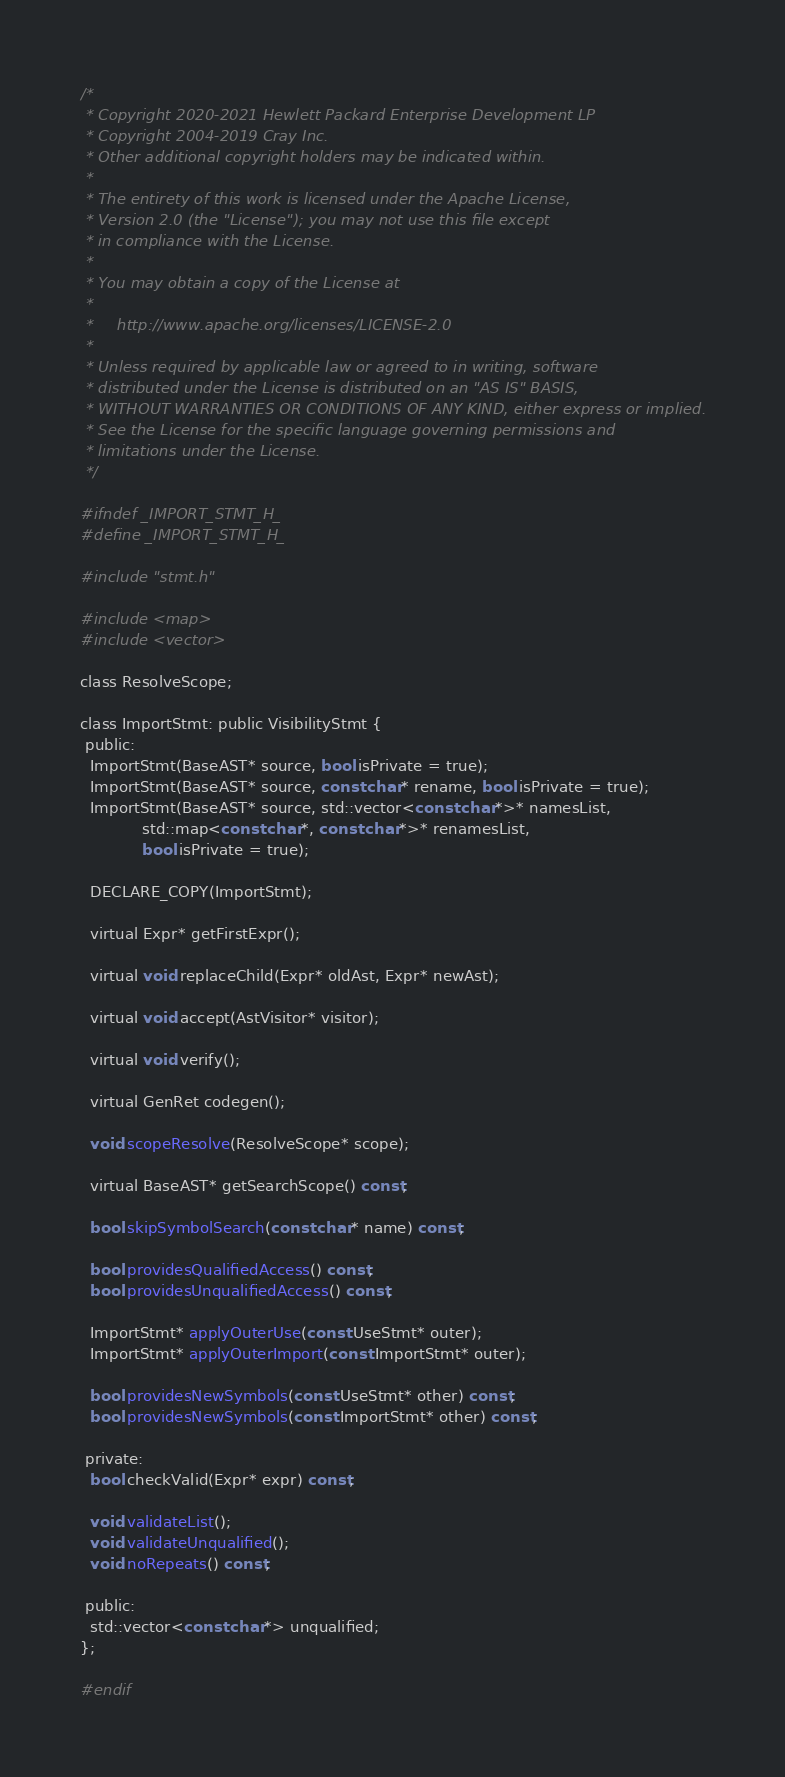Convert code to text. <code><loc_0><loc_0><loc_500><loc_500><_C_>/*
 * Copyright 2020-2021 Hewlett Packard Enterprise Development LP
 * Copyright 2004-2019 Cray Inc.
 * Other additional copyright holders may be indicated within.
 *
 * The entirety of this work is licensed under the Apache License,
 * Version 2.0 (the "License"); you may not use this file except
 * in compliance with the License.
 *
 * You may obtain a copy of the License at
 *
 *     http://www.apache.org/licenses/LICENSE-2.0
 *
 * Unless required by applicable law or agreed to in writing, software
 * distributed under the License is distributed on an "AS IS" BASIS,
 * WITHOUT WARRANTIES OR CONDITIONS OF ANY KIND, either express or implied.
 * See the License for the specific language governing permissions and
 * limitations under the License.
 */

#ifndef _IMPORT_STMT_H_
#define _IMPORT_STMT_H_

#include "stmt.h"

#include <map>
#include <vector>

class ResolveScope;

class ImportStmt: public VisibilityStmt {
 public:
  ImportStmt(BaseAST* source, bool isPrivate = true);
  ImportStmt(BaseAST* source, const char* rename, bool isPrivate = true);
  ImportStmt(BaseAST* source, std::vector<const char*>* namesList,
             std::map<const char*, const char*>* renamesList,
             bool isPrivate = true);

  DECLARE_COPY(ImportStmt);

  virtual Expr* getFirstExpr();

  virtual void replaceChild(Expr* oldAst, Expr* newAst);

  virtual void accept(AstVisitor* visitor);

  virtual void verify();

  virtual GenRet codegen();

  void scopeResolve(ResolveScope* scope);

  virtual BaseAST* getSearchScope() const;

  bool skipSymbolSearch(const char* name) const;

  bool providesQualifiedAccess() const;
  bool providesUnqualifiedAccess() const;

  ImportStmt* applyOuterUse(const UseStmt* outer);
  ImportStmt* applyOuterImport(const ImportStmt* outer);

  bool providesNewSymbols(const UseStmt* other) const;
  bool providesNewSymbols(const ImportStmt* other) const;

 private:
  bool checkValid(Expr* expr) const;

  void validateList();
  void validateUnqualified();
  void noRepeats() const;

 public:
  std::vector<const char*> unqualified;
};

#endif
</code> 